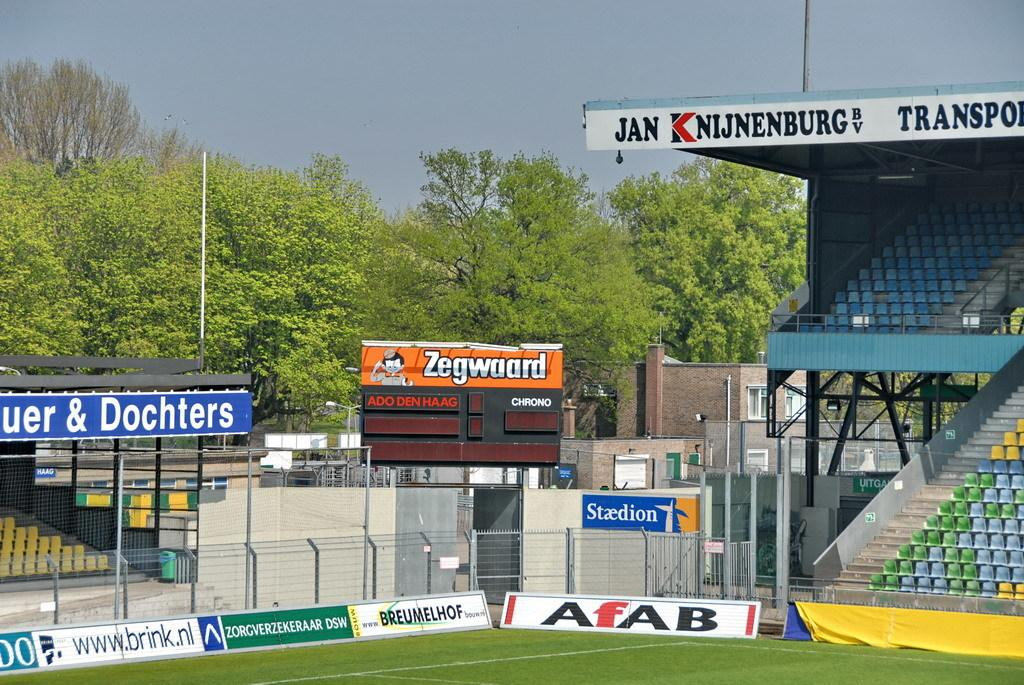Provide a one-sentence caption for the provided image. A stadium scene with an advertisement for Zegwaard. 